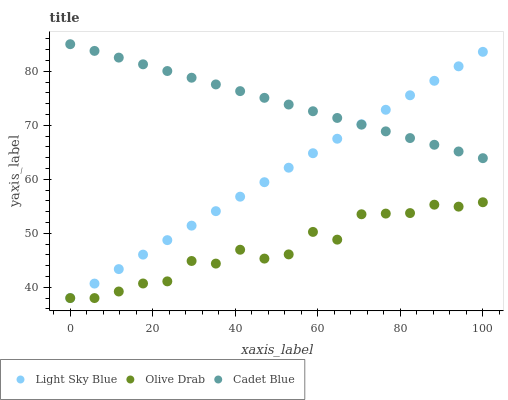Does Olive Drab have the minimum area under the curve?
Answer yes or no. Yes. Does Cadet Blue have the maximum area under the curve?
Answer yes or no. Yes. Does Light Sky Blue have the minimum area under the curve?
Answer yes or no. No. Does Light Sky Blue have the maximum area under the curve?
Answer yes or no. No. Is Light Sky Blue the smoothest?
Answer yes or no. Yes. Is Olive Drab the roughest?
Answer yes or no. Yes. Is Olive Drab the smoothest?
Answer yes or no. No. Is Light Sky Blue the roughest?
Answer yes or no. No. Does Light Sky Blue have the lowest value?
Answer yes or no. Yes. Does Cadet Blue have the highest value?
Answer yes or no. Yes. Does Light Sky Blue have the highest value?
Answer yes or no. No. Is Olive Drab less than Cadet Blue?
Answer yes or no. Yes. Is Cadet Blue greater than Olive Drab?
Answer yes or no. Yes. Does Light Sky Blue intersect Olive Drab?
Answer yes or no. Yes. Is Light Sky Blue less than Olive Drab?
Answer yes or no. No. Is Light Sky Blue greater than Olive Drab?
Answer yes or no. No. Does Olive Drab intersect Cadet Blue?
Answer yes or no. No. 